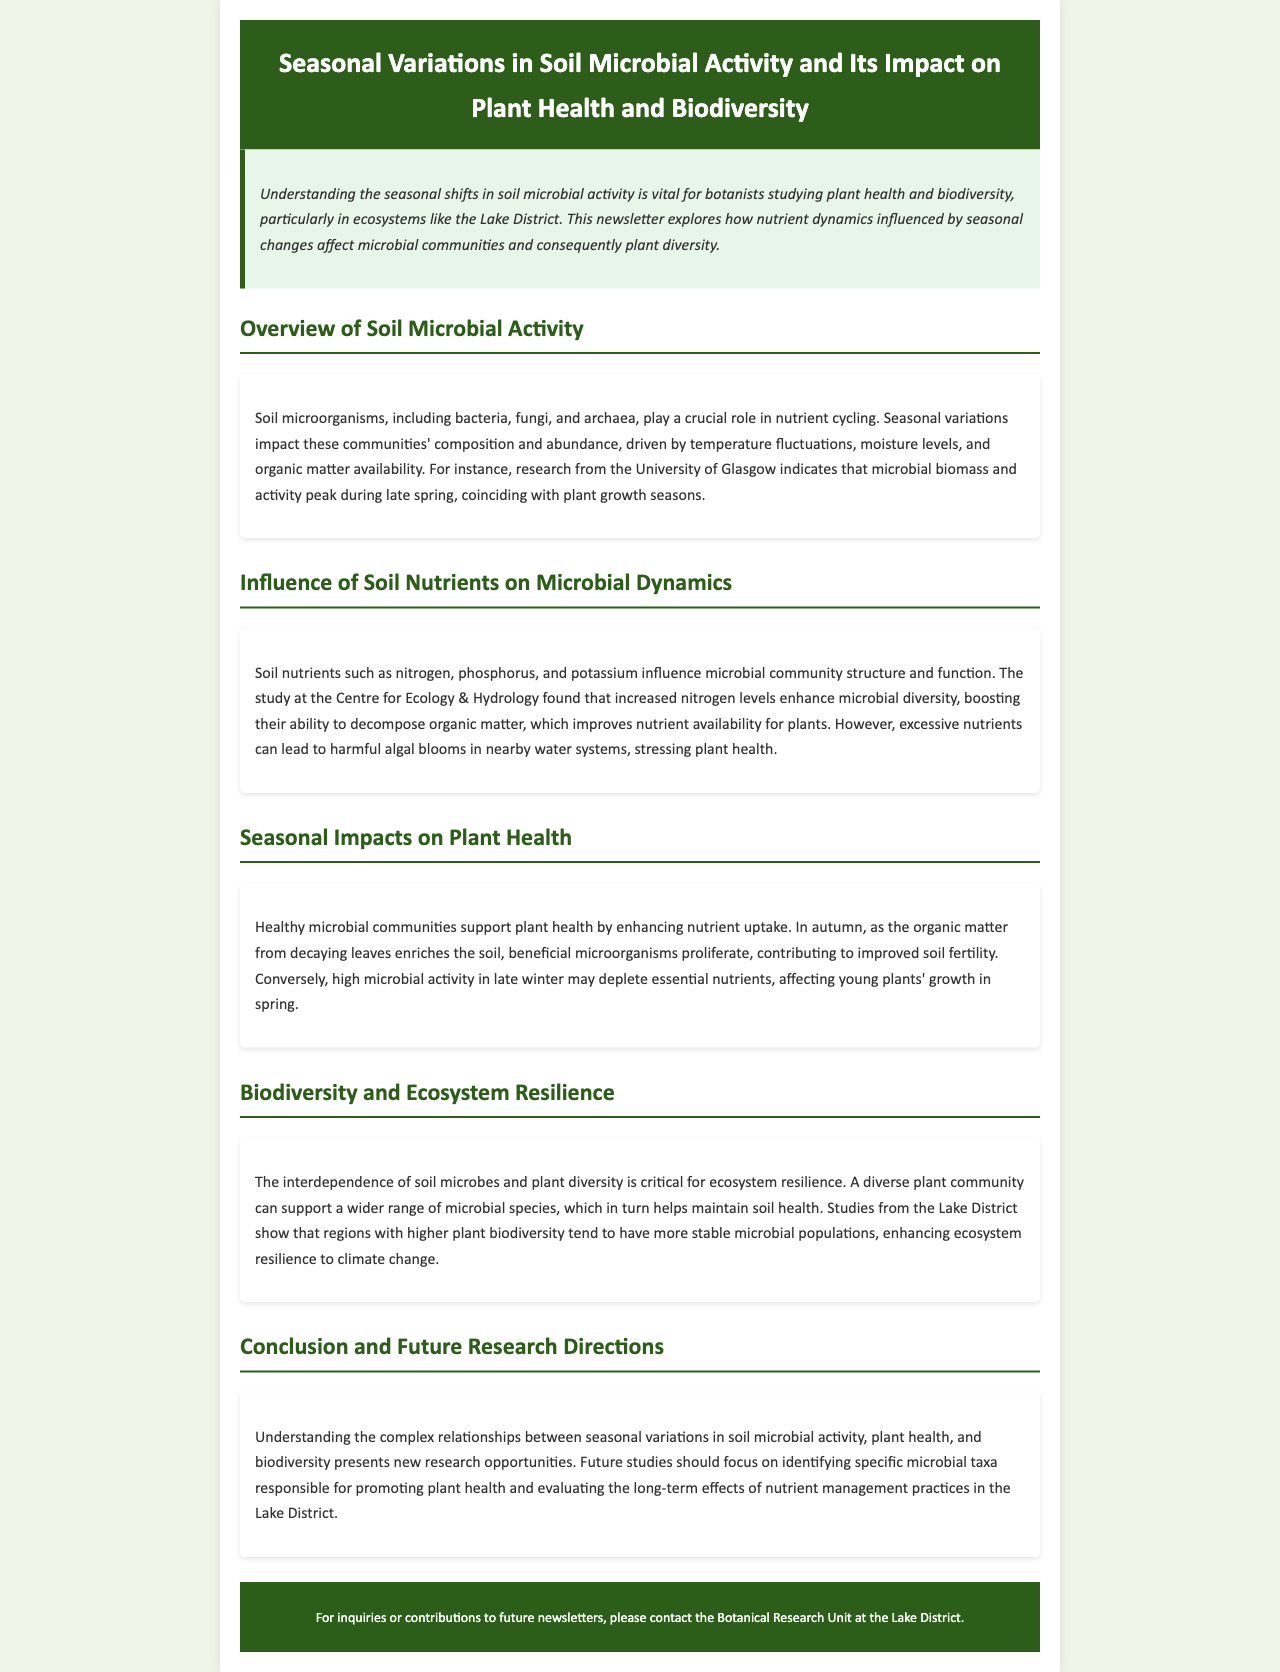What is the main focus of the newsletter? The newsletter focuses on the relationship between seasonal variations in soil microbial activity and its impact on plant health and biodiversity.
Answer: Seasonal variations in soil microbial activity and its impact on plant health and biodiversity Which microorganisms are mentioned in the overview? The overview mentions soil microorganisms such as bacteria, fungi, and archaea.
Answer: Bacteria, fungi, and archaea What nutrient is noted for enhancing microbial diversity? The newsletter states that increased nitrogen levels enhance microbial diversity.
Answer: Nitrogen In which season do microbial biomass and activity peak? Research from the University of Glasgow indicates that microbial biomass and activity peak during late spring.
Answer: Late spring What happens to microbial activity in autumn? The newsletter mentions that beneficial microorganisms proliferate in autumn due to decaying organic matter enriching the soil.
Answer: Beneficial microorganisms proliferate Which region is highlighted for studies on plant biodiversity? Studies from the Lake District show the relationships between plant biodiversity and microbial populations.
Answer: Lake District What is a consequence of excessive nutrients in soils? The article mentions that excessive nutrients can lead to harmful algal blooms in nearby water systems.
Answer: Harmful algal blooms What future research direction is suggested in the conclusion? The conclusion suggests future studies should focus on identifying specific microbial taxa responsible for promoting plant health.
Answer: Identifying specific microbial taxa 